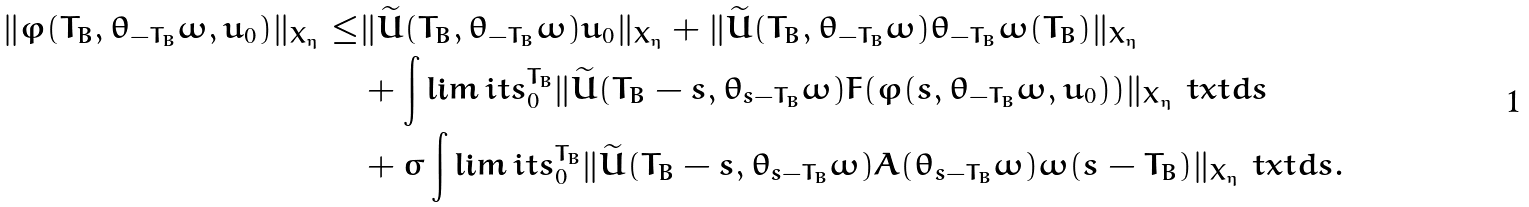Convert formula to latex. <formula><loc_0><loc_0><loc_500><loc_500>\| \varphi ( T _ { B } , \theta _ { - T _ { B } } \omega , u _ { 0 } ) \| _ { X _ { \eta } } \leq & \| \widetilde { U } ( T _ { B } , \theta _ { - T _ { B } } \omega ) u _ { 0 } \| _ { X _ { \eta } } + \| \widetilde { U } ( T _ { B } , \theta _ { - T _ { B } } \omega ) \theta _ { - T _ { B } } \omega ( T _ { B } ) \| _ { X _ { \eta } } \\ & + \int \lim i t s _ { 0 } ^ { T _ { B } } \| \widetilde { U } ( T _ { B } - s , \theta _ { s - T _ { B } } \omega ) F ( \varphi ( s , \theta _ { - T _ { B } } \omega , u _ { 0 } ) ) \| _ { X _ { \eta } } \ t x t d s \\ & + \sigma \int \lim i t s _ { 0 } ^ { T _ { B } } \| \widetilde { U } ( T _ { B } - s , \theta _ { s - T _ { B } } \omega ) A ( \theta _ { s - T _ { B } } \omega ) \omega ( s - T _ { B } ) \| _ { X _ { \eta } } \ t x t d s .</formula> 